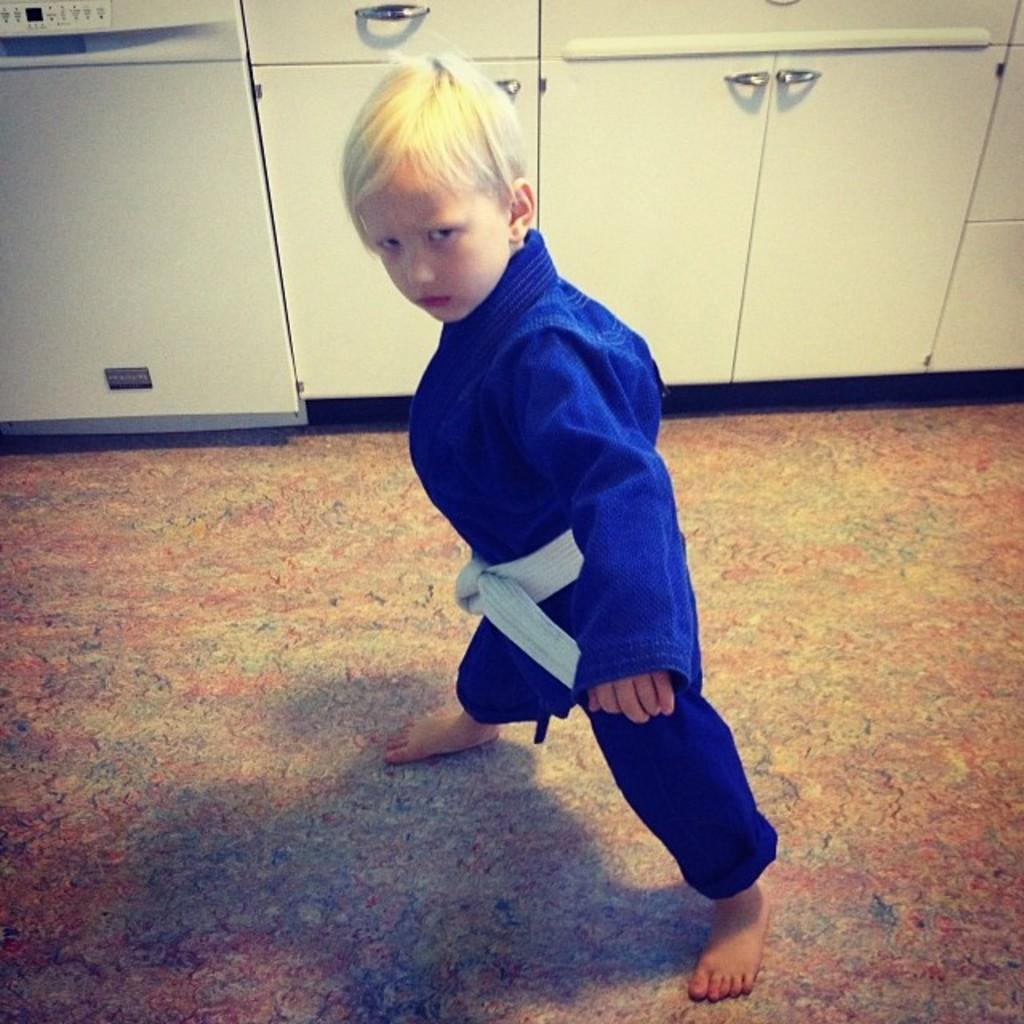What is the main subject of the image? The main subject of the image is a kid standing on the floor. What can be seen in the background of the image? In the background of the image, there are cupboards and a dishwasher. What type of caption is written on the kid's shirt in the image? There is no caption visible on the kid's shirt in the image. How many cents are visible on the floor in the image? There are no cents visible on the floor in the image. 